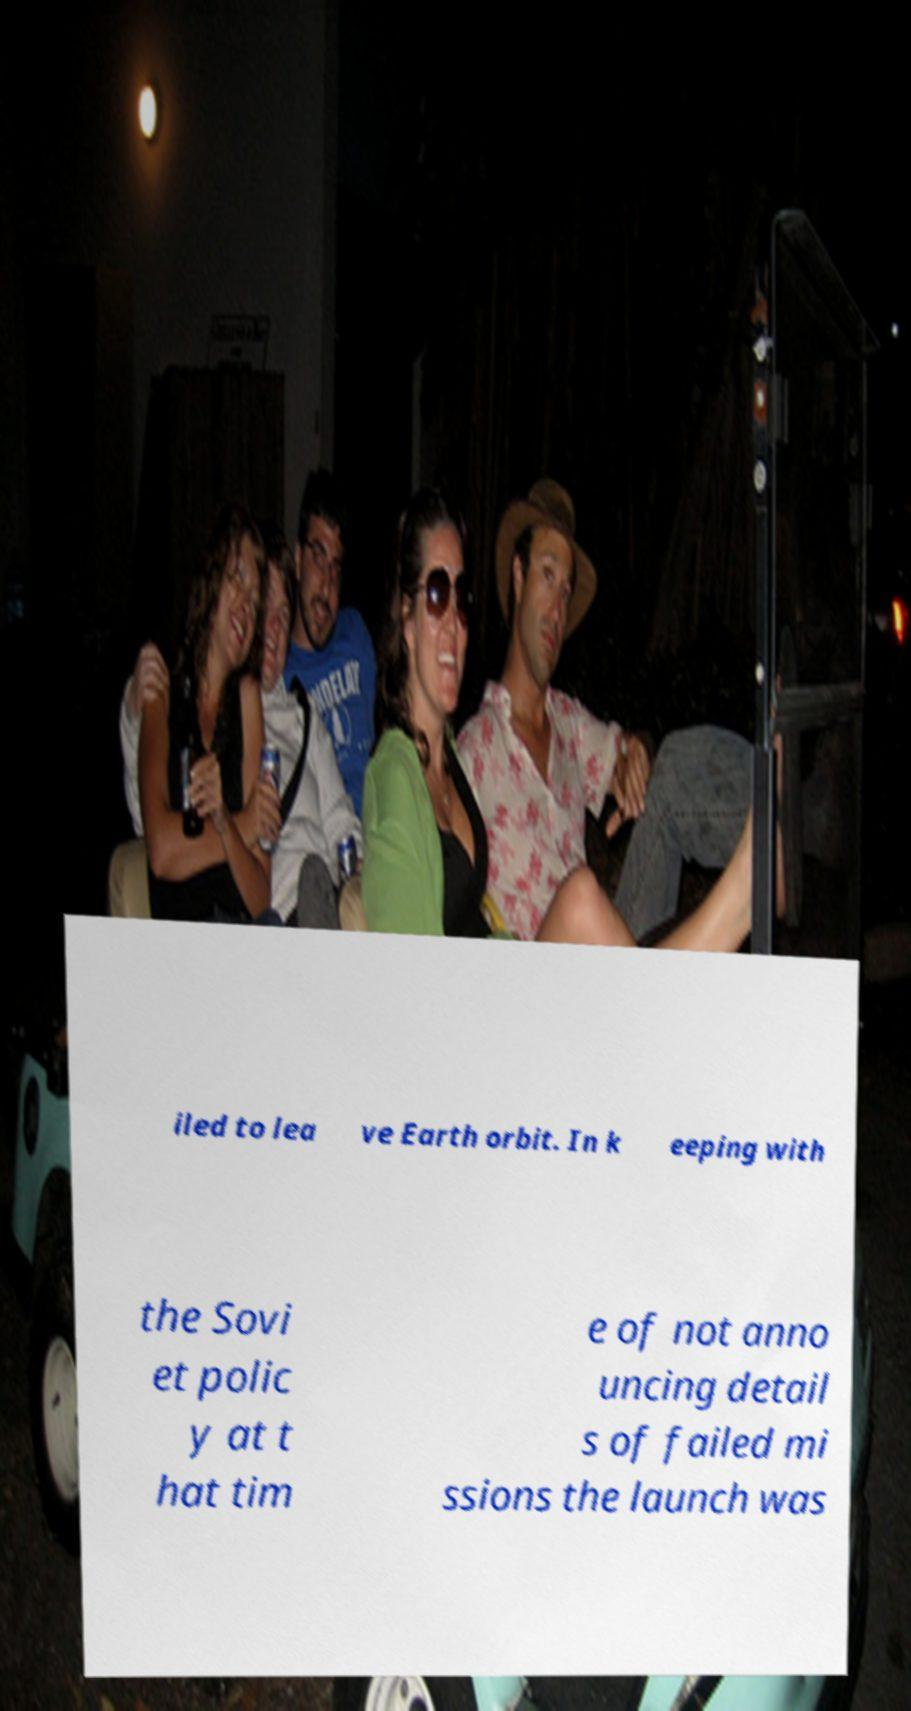I need the written content from this picture converted into text. Can you do that? iled to lea ve Earth orbit. In k eeping with the Sovi et polic y at t hat tim e of not anno uncing detail s of failed mi ssions the launch was 